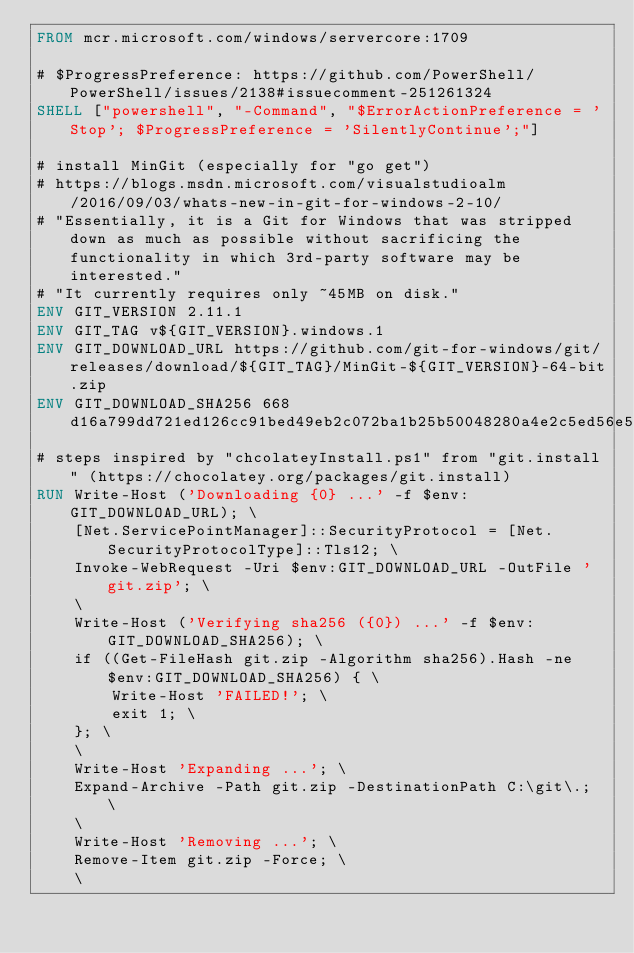Convert code to text. <code><loc_0><loc_0><loc_500><loc_500><_Dockerfile_>FROM mcr.microsoft.com/windows/servercore:1709

# $ProgressPreference: https://github.com/PowerShell/PowerShell/issues/2138#issuecomment-251261324
SHELL ["powershell", "-Command", "$ErrorActionPreference = 'Stop'; $ProgressPreference = 'SilentlyContinue';"]

# install MinGit (especially for "go get")
# https://blogs.msdn.microsoft.com/visualstudioalm/2016/09/03/whats-new-in-git-for-windows-2-10/
# "Essentially, it is a Git for Windows that was stripped down as much as possible without sacrificing the functionality in which 3rd-party software may be interested."
# "It currently requires only ~45MB on disk."
ENV GIT_VERSION 2.11.1
ENV GIT_TAG v${GIT_VERSION}.windows.1
ENV GIT_DOWNLOAD_URL https://github.com/git-for-windows/git/releases/download/${GIT_TAG}/MinGit-${GIT_VERSION}-64-bit.zip
ENV GIT_DOWNLOAD_SHA256 668d16a799dd721ed126cc91bed49eb2c072ba1b25b50048280a4e2c5ed56e59
# steps inspired by "chcolateyInstall.ps1" from "git.install" (https://chocolatey.org/packages/git.install)
RUN Write-Host ('Downloading {0} ...' -f $env:GIT_DOWNLOAD_URL); \
	[Net.ServicePointManager]::SecurityProtocol = [Net.SecurityProtocolType]::Tls12; \
	Invoke-WebRequest -Uri $env:GIT_DOWNLOAD_URL -OutFile 'git.zip'; \
	\
	Write-Host ('Verifying sha256 ({0}) ...' -f $env:GIT_DOWNLOAD_SHA256); \
	if ((Get-FileHash git.zip -Algorithm sha256).Hash -ne $env:GIT_DOWNLOAD_SHA256) { \
		Write-Host 'FAILED!'; \
		exit 1; \
	}; \
	\
	Write-Host 'Expanding ...'; \
	Expand-Archive -Path git.zip -DestinationPath C:\git\.; \
	\
	Write-Host 'Removing ...'; \
	Remove-Item git.zip -Force; \
	\</code> 